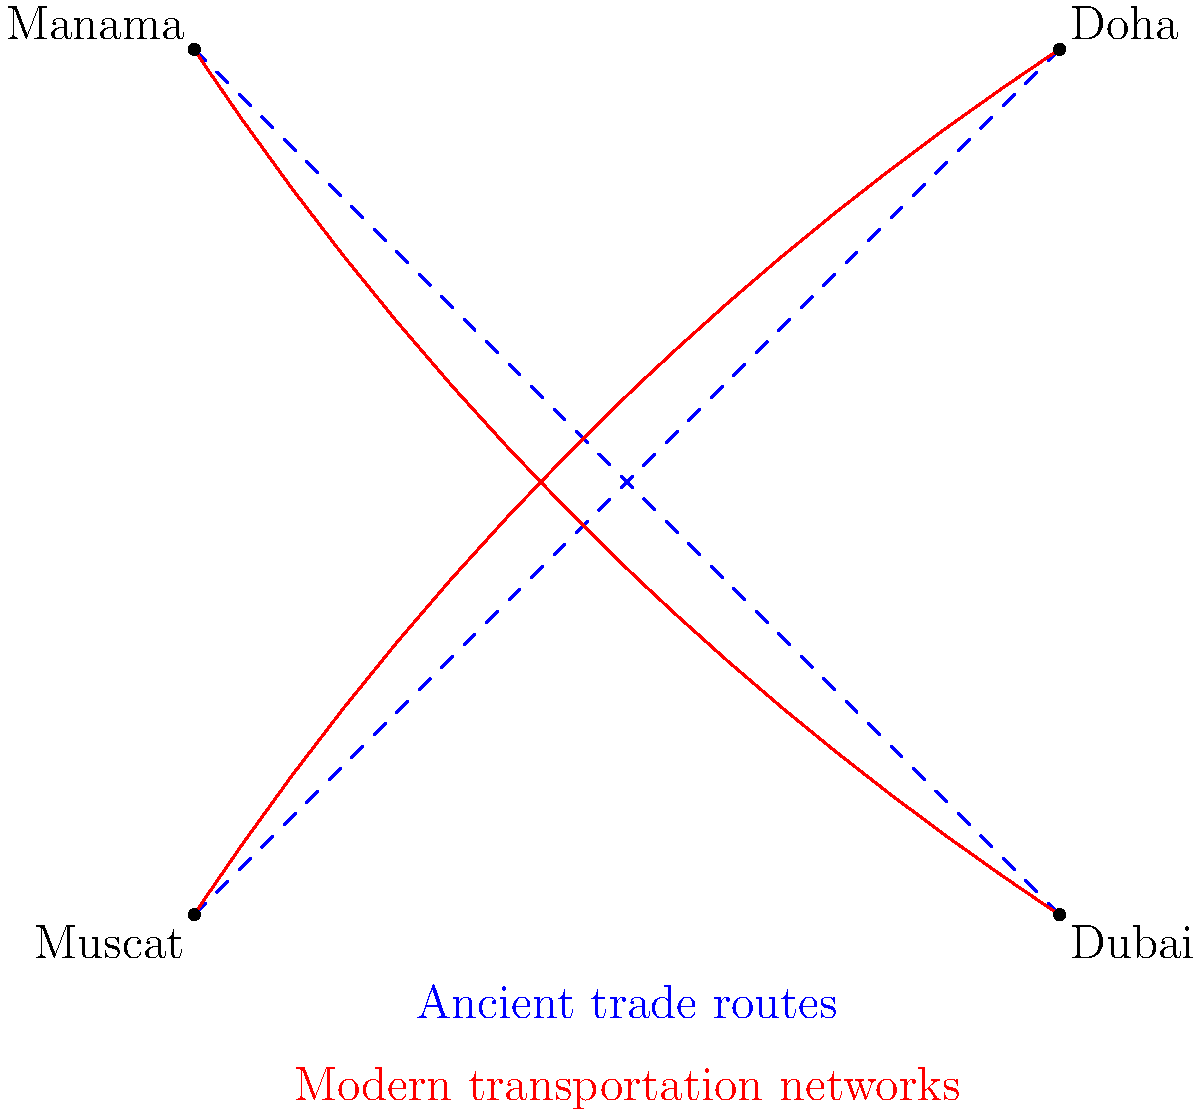Which two GCC cities show the most significant alignment between ancient trade routes and modern transportation networks based on the diagram? To answer this question, we need to analyze the alignment between the ancient trade routes (shown as blue dashed lines) and the modern transportation networks (shown as red solid lines) connecting the four GCC cities depicted in the diagram. Let's examine each pair of cities:

1. Muscat to Doha:
   The ancient route is a straight line, while the modern route closely follows it with a slight curve. This shows a high degree of alignment.

2. Manama to Dubai:
   Similar to the Muscat-Doha route, the ancient and modern routes between Manama and Dubai are closely aligned, with the modern route having a slight curve.

3. Muscat to Dubai:
   There is no direct ancient or modern route shown between these cities in the diagram.

4. Manama to Doha:
   There is no direct ancient or modern route shown between these cities in the diagram.

Comparing the two pairs that have both ancient and modern routes (Muscat-Doha and Manama-Dubai), we can observe that both show a high degree of alignment. However, the Muscat-Doha route appears to have a slightly closer alignment, with the modern route following the ancient route more closely.

Therefore, the two GCC cities that show the most significant alignment between ancient trade routes and modern transportation networks are Muscat and Doha.
Answer: Muscat and Doha 